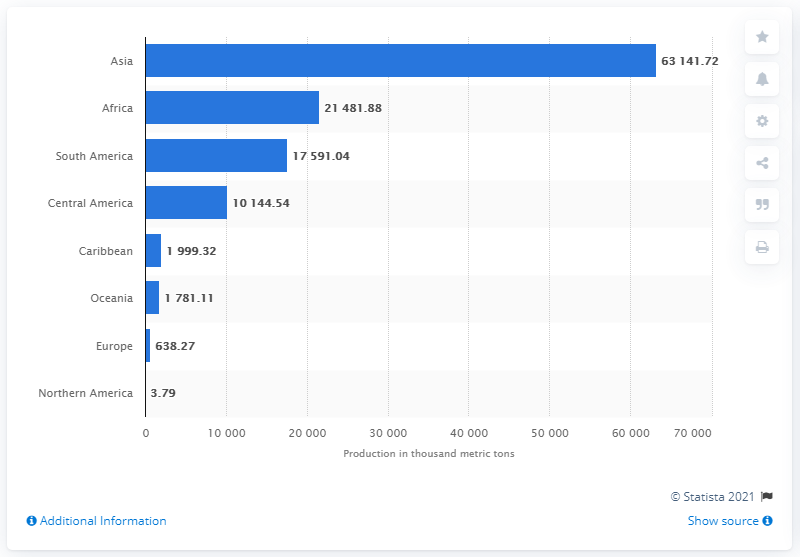Draw attention to some important aspects in this diagram. According to information from 2019, the region that produced the most bananas was Asia, with a total of 63.14 million metric tons. 